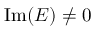Convert formula to latex. <formula><loc_0><loc_0><loc_500><loc_500>I m ( E ) \ne 0</formula> 